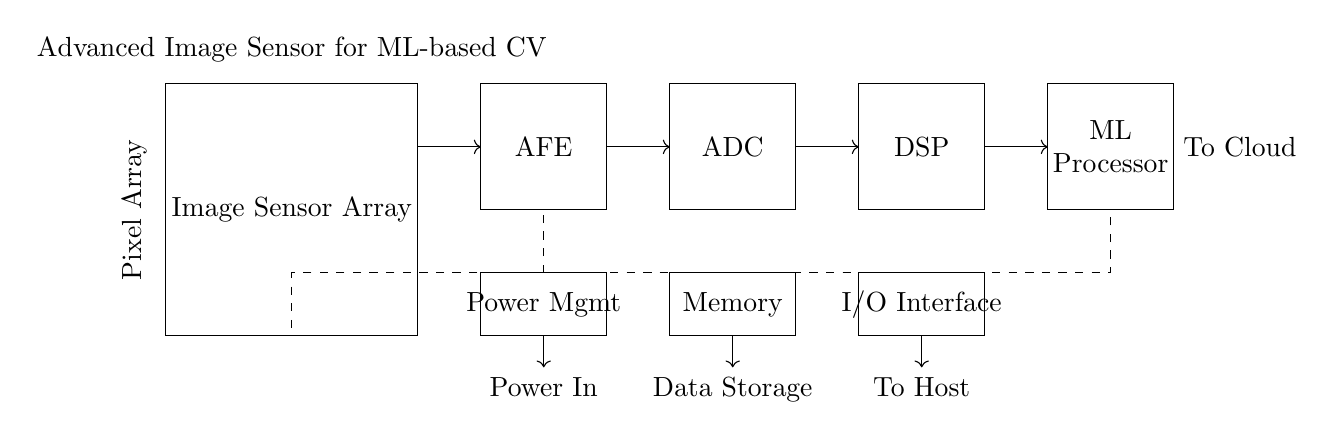What is the main component representing the image capture functionality? The main component for image capture is the "Image Sensor Array," which is indicated as the first block in the circuit diagram.
Answer: Image Sensor Array What is the role of the ADC in the circuit? The ADC, or Analog-to-Digital Converter, converts the analog signals from the AFE into digital signals for processing. This can be inferred from its position after the AFE in the flow of data.
Answer: Convert analog signals to digital Which component is responsible for processing the data after conversion? The "DSP," or Digital Signal Processor, follows the ADC in the diagram and is responsible for processing the digital signals received from it, highlighting its role in data analysis.
Answer: DSP What is the function of the ML Processor in this circuit? The ML Processor is used for executing machine learning algorithms, which is essential for advanced computer vision tasks. It's positioned after the DSP, indicating it processes the output from there for intelligent analysis.
Answer: Execute machine learning algorithms How does power flow to the different components in the circuit? Power flows from the Power Management block, which is connected to several components via dashed lines, indicating power distribution to the AFE, ADC, DSP, and other sections of the circuit.
Answer: Through Power Management How many main stages are there in the processing pipeline of this circuit? The processing pipeline consists of five main stages: Image Sensor Array, AFE, ADC, DSP, and ML Processor, each represented as a separate block in the circuit diagram.
Answer: Five stages What is indicated by the connections shown as arrows in the circuit? The arrows represent the direction of data flow between various components in the circuit, showing how the processed information moves from the image sensor to the ML Processor and finally to the cloud.
Answer: Direction of data flow 